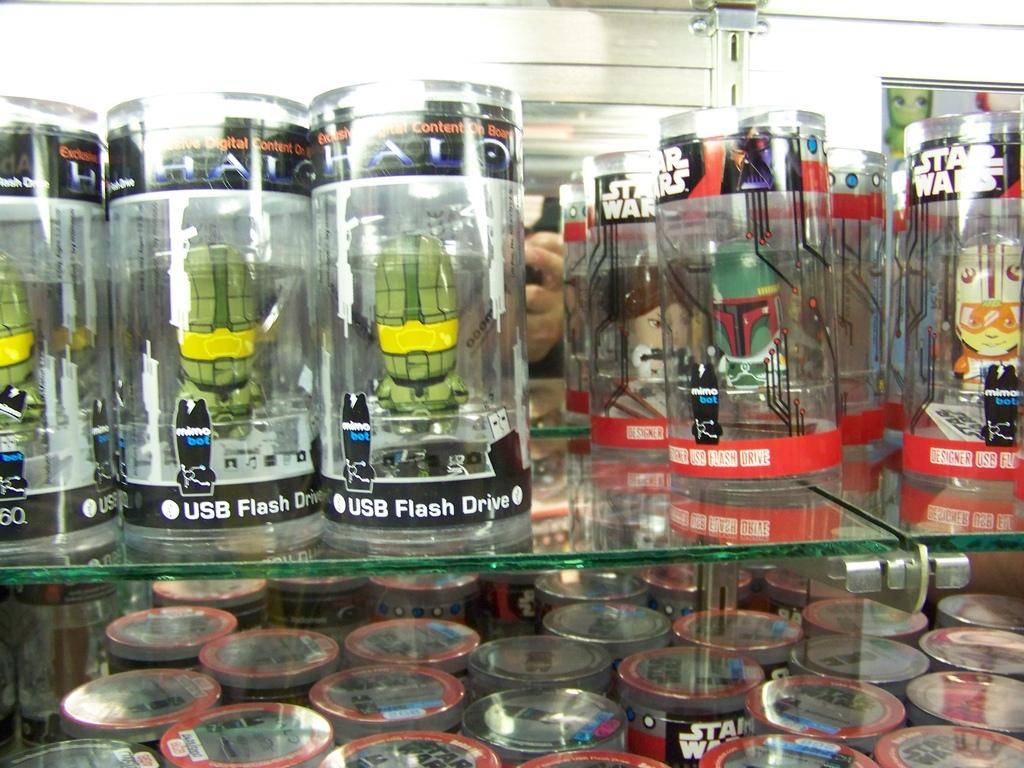<image>
Write a terse but informative summary of the picture. Some bottles with USB Flash drive along the bottom. 